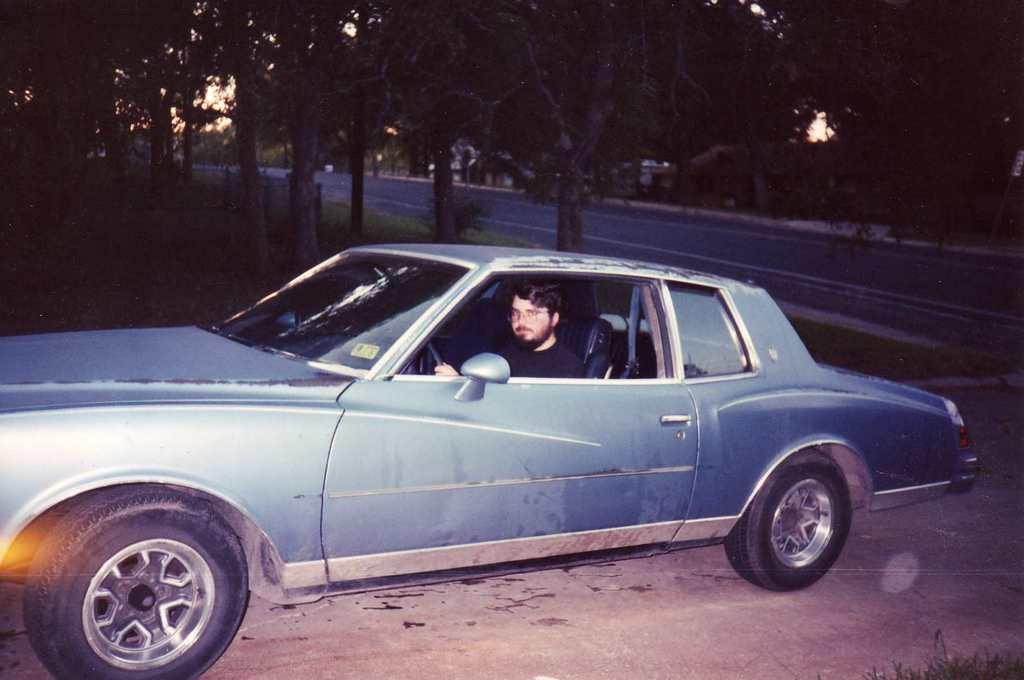What is the person doing in the image? There is a person sitting inside a blue car in the image. What can be seen in the background of the image? There are trees and a road visible in the background. What are the ants doing on the person's thought in the image? There are no ants or thoughts present in the image; it only shows a person sitting in a blue car with trees and a road in the background. 